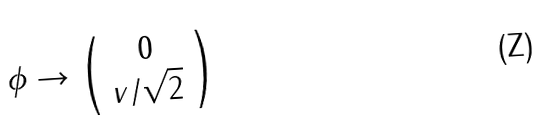<formula> <loc_0><loc_0><loc_500><loc_500>\phi \rightarrow \left ( \begin{array} { c } 0 \\ v / \sqrt { 2 } \end{array} \right )</formula> 